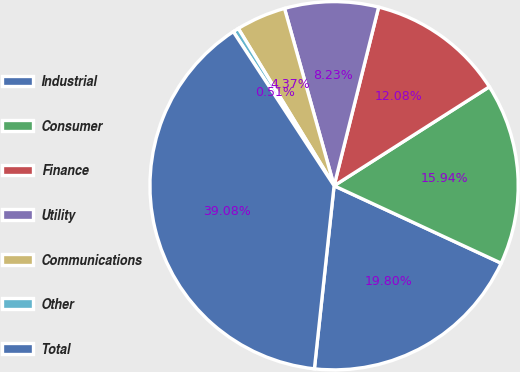Convert chart. <chart><loc_0><loc_0><loc_500><loc_500><pie_chart><fcel>Industrial<fcel>Consumer<fcel>Finance<fcel>Utility<fcel>Communications<fcel>Other<fcel>Total<nl><fcel>19.8%<fcel>15.94%<fcel>12.08%<fcel>8.23%<fcel>4.37%<fcel>0.51%<fcel>39.08%<nl></chart> 